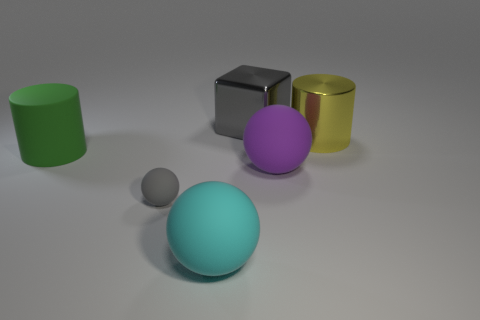Subtract all large balls. How many balls are left? 1 Subtract 0 cyan cubes. How many objects are left? 6 Subtract all blocks. How many objects are left? 5 Subtract 2 spheres. How many spheres are left? 1 Subtract all blue cubes. Subtract all brown cylinders. How many cubes are left? 1 Subtract all gray cubes. How many gray spheres are left? 1 Subtract all rubber balls. Subtract all big shiny blocks. How many objects are left? 2 Add 1 green cylinders. How many green cylinders are left? 2 Add 2 large matte spheres. How many large matte spheres exist? 4 Add 4 metal cubes. How many objects exist? 10 